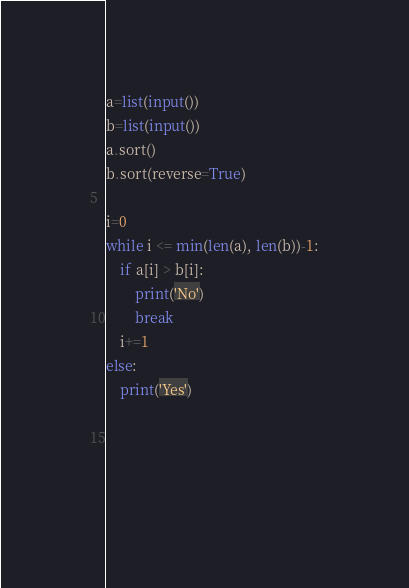Convert code to text. <code><loc_0><loc_0><loc_500><loc_500><_Python_>a=list(input())
b=list(input())
a.sort()
b.sort(reverse=True)

i=0
while i <= min(len(a), len(b))-1:
    if a[i] > b[i]:
        print('No')
        break     
    i+=1
else:
    print('Yes')



    </code> 